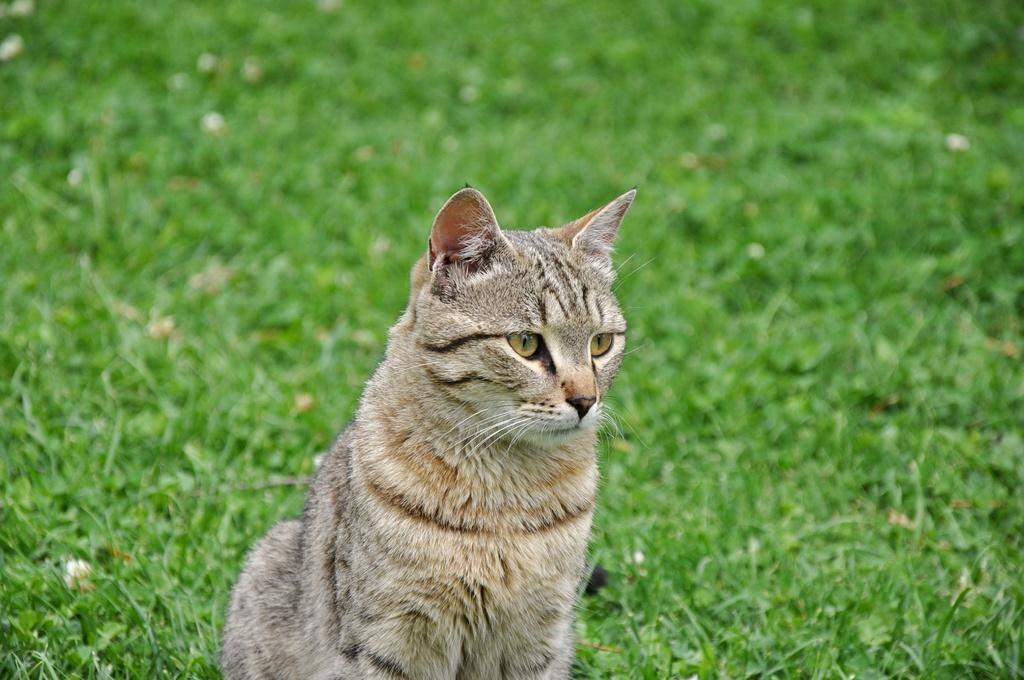What is the main subject of the image? There is a cat in the center of the image. What type of environment is visible in the background of the image? There is grass visible in the background of the image. What type of ship can be seen sailing in the background of the image? There is no ship present in the image; it features a cat and grass in the background. What is the zephyr doing in the image? There is no zephyr present in the image; it is a term used to describe a gentle breeze, and there is no mention of wind or weather in the provided facts. 